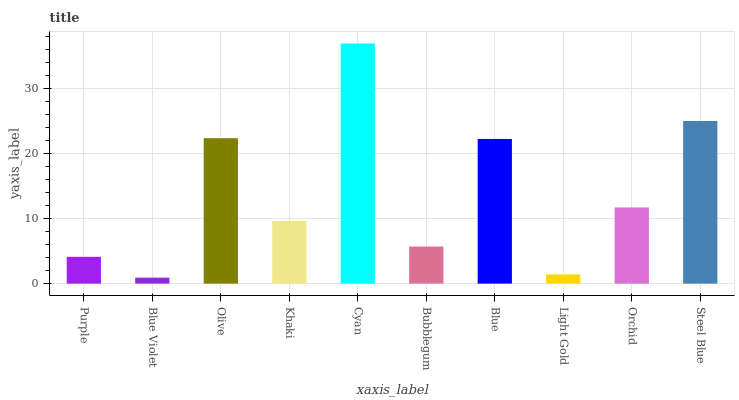Is Blue Violet the minimum?
Answer yes or no. Yes. Is Cyan the maximum?
Answer yes or no. Yes. Is Olive the minimum?
Answer yes or no. No. Is Olive the maximum?
Answer yes or no. No. Is Olive greater than Blue Violet?
Answer yes or no. Yes. Is Blue Violet less than Olive?
Answer yes or no. Yes. Is Blue Violet greater than Olive?
Answer yes or no. No. Is Olive less than Blue Violet?
Answer yes or no. No. Is Orchid the high median?
Answer yes or no. Yes. Is Khaki the low median?
Answer yes or no. Yes. Is Blue the high median?
Answer yes or no. No. Is Blue the low median?
Answer yes or no. No. 